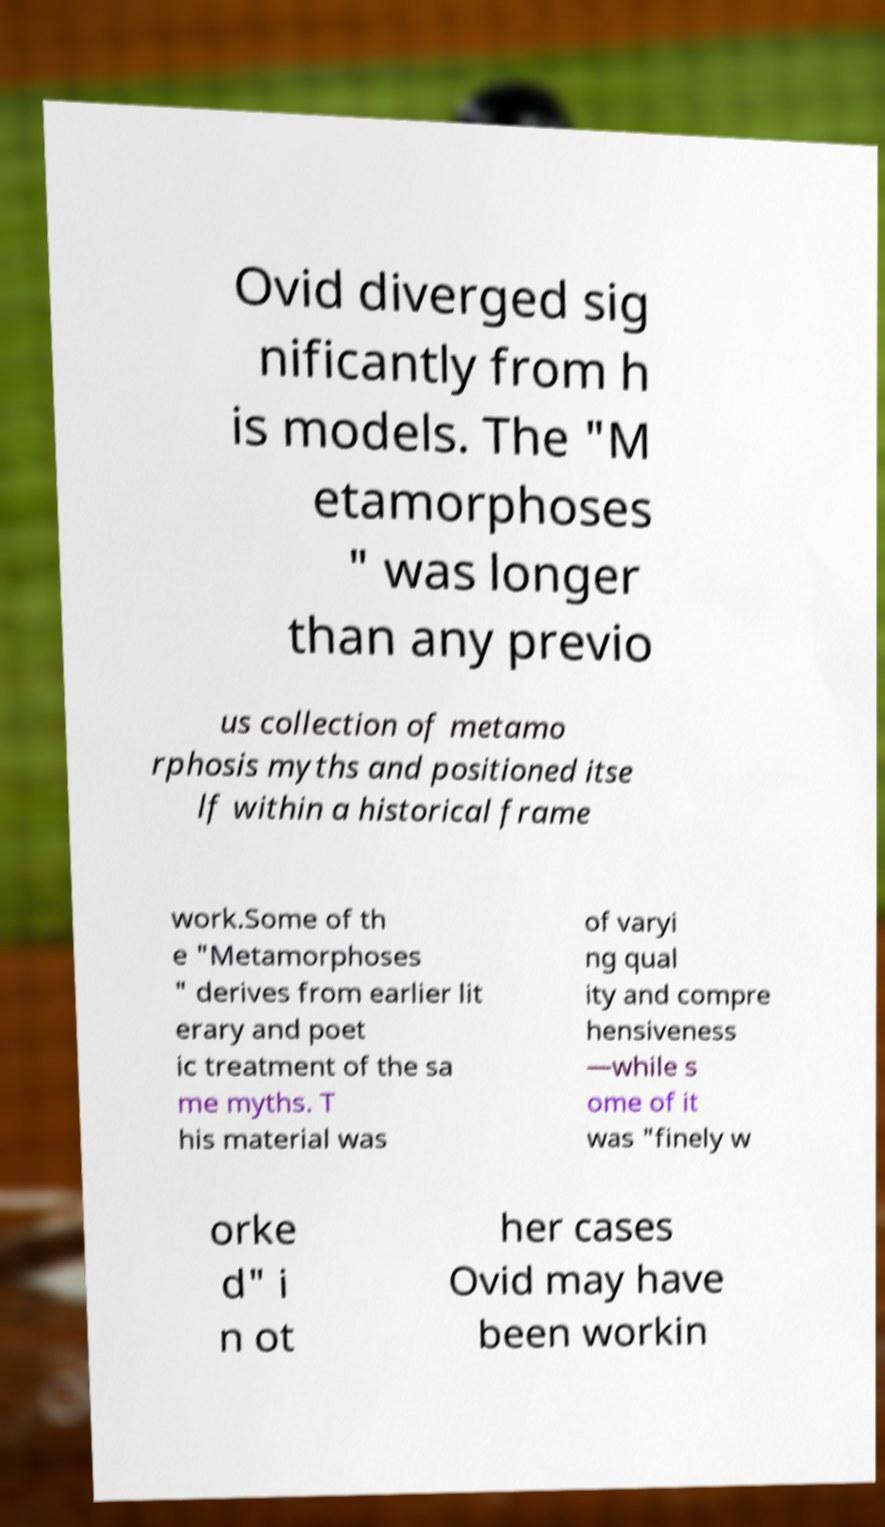Please read and relay the text visible in this image. What does it say? Ovid diverged sig nificantly from h is models. The "M etamorphoses " was longer than any previo us collection of metamo rphosis myths and positioned itse lf within a historical frame work.Some of th e "Metamorphoses " derives from earlier lit erary and poet ic treatment of the sa me myths. T his material was of varyi ng qual ity and compre hensiveness —while s ome of it was "finely w orke d" i n ot her cases Ovid may have been workin 